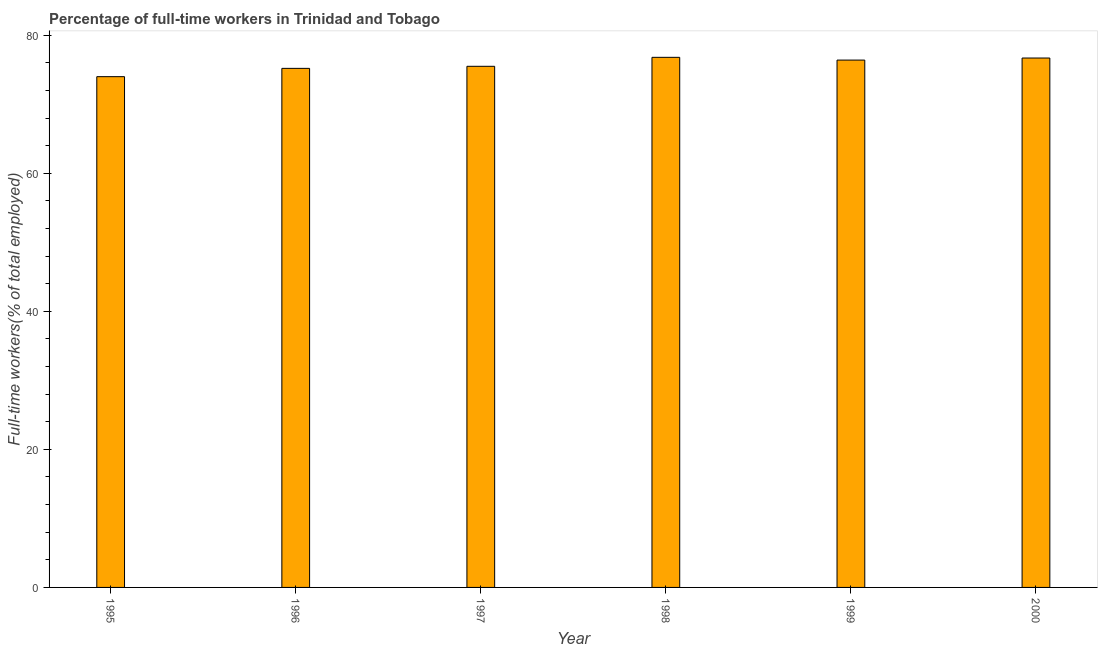Does the graph contain any zero values?
Your answer should be very brief. No. Does the graph contain grids?
Provide a short and direct response. No. What is the title of the graph?
Ensure brevity in your answer.  Percentage of full-time workers in Trinidad and Tobago. What is the label or title of the X-axis?
Ensure brevity in your answer.  Year. What is the label or title of the Y-axis?
Offer a terse response. Full-time workers(% of total employed). What is the percentage of full-time workers in 1998?
Offer a terse response. 76.8. Across all years, what is the maximum percentage of full-time workers?
Give a very brief answer. 76.8. In which year was the percentage of full-time workers maximum?
Provide a succinct answer. 1998. In which year was the percentage of full-time workers minimum?
Provide a short and direct response. 1995. What is the sum of the percentage of full-time workers?
Your answer should be compact. 454.6. What is the average percentage of full-time workers per year?
Offer a very short reply. 75.77. What is the median percentage of full-time workers?
Keep it short and to the point. 75.95. In how many years, is the percentage of full-time workers greater than 24 %?
Your answer should be compact. 6. Do a majority of the years between 2000 and 1996 (inclusive) have percentage of full-time workers greater than 24 %?
Your response must be concise. Yes. What is the ratio of the percentage of full-time workers in 1995 to that in 1999?
Ensure brevity in your answer.  0.97. Is the difference between the percentage of full-time workers in 1996 and 1998 greater than the difference between any two years?
Your answer should be very brief. No. What is the difference between the highest and the second highest percentage of full-time workers?
Give a very brief answer. 0.1. What is the difference between the highest and the lowest percentage of full-time workers?
Your answer should be very brief. 2.8. In how many years, is the percentage of full-time workers greater than the average percentage of full-time workers taken over all years?
Your answer should be compact. 3. How many bars are there?
Offer a terse response. 6. How many years are there in the graph?
Provide a short and direct response. 6. What is the Full-time workers(% of total employed) of 1996?
Your response must be concise. 75.2. What is the Full-time workers(% of total employed) of 1997?
Make the answer very short. 75.5. What is the Full-time workers(% of total employed) in 1998?
Offer a very short reply. 76.8. What is the Full-time workers(% of total employed) in 1999?
Ensure brevity in your answer.  76.4. What is the Full-time workers(% of total employed) of 2000?
Ensure brevity in your answer.  76.7. What is the difference between the Full-time workers(% of total employed) in 1995 and 1996?
Offer a very short reply. -1.2. What is the difference between the Full-time workers(% of total employed) in 1995 and 1997?
Your answer should be compact. -1.5. What is the difference between the Full-time workers(% of total employed) in 1995 and 1999?
Provide a short and direct response. -2.4. What is the difference between the Full-time workers(% of total employed) in 1995 and 2000?
Offer a very short reply. -2.7. What is the difference between the Full-time workers(% of total employed) in 1996 and 1998?
Ensure brevity in your answer.  -1.6. What is the difference between the Full-time workers(% of total employed) in 1996 and 1999?
Give a very brief answer. -1.2. What is the difference between the Full-time workers(% of total employed) in 1996 and 2000?
Give a very brief answer. -1.5. What is the difference between the Full-time workers(% of total employed) in 1997 and 1999?
Offer a terse response. -0.9. What is the difference between the Full-time workers(% of total employed) in 1997 and 2000?
Your response must be concise. -1.2. What is the difference between the Full-time workers(% of total employed) in 1998 and 2000?
Your answer should be very brief. 0.1. What is the difference between the Full-time workers(% of total employed) in 1999 and 2000?
Make the answer very short. -0.3. What is the ratio of the Full-time workers(% of total employed) in 1995 to that in 1997?
Provide a succinct answer. 0.98. What is the ratio of the Full-time workers(% of total employed) in 1995 to that in 1999?
Your answer should be very brief. 0.97. What is the ratio of the Full-time workers(% of total employed) in 1996 to that in 1997?
Offer a terse response. 1. What is the ratio of the Full-time workers(% of total employed) in 1996 to that in 1999?
Your answer should be very brief. 0.98. What is the ratio of the Full-time workers(% of total employed) in 1997 to that in 1998?
Keep it short and to the point. 0.98. What is the ratio of the Full-time workers(% of total employed) in 1997 to that in 1999?
Offer a terse response. 0.99. 